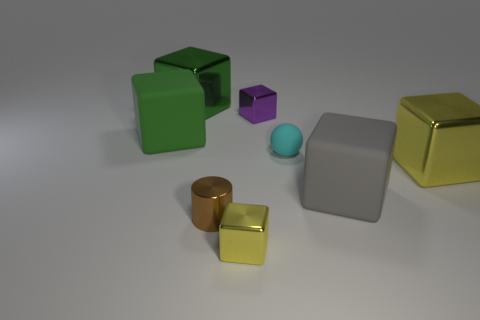Subtract 3 blocks. How many blocks are left? 3 Subtract all green cubes. How many cubes are left? 4 Subtract all large yellow metallic cubes. How many cubes are left? 5 Subtract all brown cubes. Subtract all green balls. How many cubes are left? 6 Add 1 large matte cubes. How many objects exist? 9 Subtract all spheres. How many objects are left? 7 Subtract 0 green cylinders. How many objects are left? 8 Subtract all large cyan rubber blocks. Subtract all big metallic things. How many objects are left? 6 Add 4 cyan spheres. How many cyan spheres are left? 5 Add 7 tiny matte things. How many tiny matte things exist? 8 